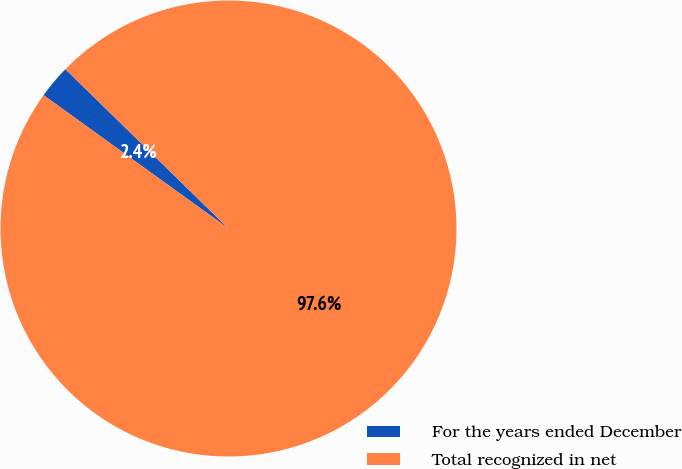Convert chart to OTSL. <chart><loc_0><loc_0><loc_500><loc_500><pie_chart><fcel>For the years ended December<fcel>Total recognized in net<nl><fcel>2.37%<fcel>97.63%<nl></chart> 